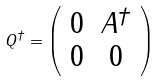Convert formula to latex. <formula><loc_0><loc_0><loc_500><loc_500>Q ^ { \dagger } = \left ( \begin{array} { c c } 0 & A ^ { \dagger } \\ 0 & 0 \end{array} \right )</formula> 